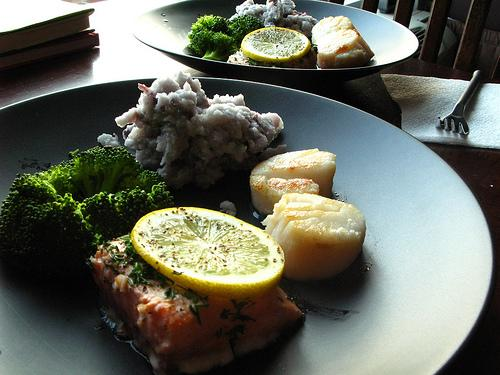What item is resting on the white napkin, and how would you describe it? A silver fork is resting on the white napkin, appearing clean and ready for use. Provide a high-level description of the entire scene captured in the image. The image shows a well-prepared seafood dish with broccoli and rice on a large white plate, placed on a wooden table with a silver fork on a white napkin, next to a stack of books and a wooden chair. Count the number of books present in the image and describe their state. There are two books in the image, neatly stacked on a table. Point out the two types of seafood on the white plate and describe how they are cooked. The plate has perfectly cooked white sea scallops and lemon herb cooked salmon, both visibly garnished with green herbs. How would you describe the arrangement and presentation of the seafood dish on the large white plate? The seafood dish is perfectly plated on the large white plate, with the cooked salmon, scallops, and broccoli well-arranged and garnished with green herbs and lemon. Describe the furniture visible in the image and its position relative to the food. A brown wooden chair with back slats is visible at the top-right corner of the image, placed beside the table with the food. What type of vegetable is presented along with the seafood, and where is it positioned in the image? Cooked green broccoli is presented with the seafood, positioned at the left side of the plate in the image. Describe the interactions between the objects in the image in terms of their placement and function. The seafood, rice, and broccoli are placed together on the white plate, creating an appetizing meal. A silver fork rests on a white napkin, prepared for use during the meal. The wooden table provides a surface for both the food and the stack of books, while the wooden chair offers seating for the person who will enjoy the meal. What is the sentiment implied by the visual elements in the image? The sentiment is positive, as the image portrays an appetizing and well-presented meal, inviting the viewer to enjoy a seafood feast. What is the main ingredient of the dish next to the broccoli? Salmon Chair and books bring delight. A moment of peace, captured with care. Choose the correct description of the plate with the seafood meal: (a) red plate with vegetables, (b) blue plate with seafood and rice, (c) green plate with fruits, (d) black plate with pasta (b) blue plate with seafood and rice Describe the appearance of the cooked salmon dish in the image. The cooked salmon dish has a lemon slice on top, green herbs, and appears pink in color. Is there a red fork on a green napkin? There is a silver fork mentioned repeatedly, but not a red one. Similarly, there are mentions of a white napkin and a blue cloth napkin but not a green one. Identify the event in the image. The event is a meal setup with plates of seafood dishes and utensils. Can you point to the pizza in the image? There is no mention of pizza in any of the captions, only various seafood dishes and side dishes like rice, broccoli, and lemon are mentioned. Identify if there are any diagrams in the image. No Create a story using the objects in the image. Once upon a time, a delicious seafood meal of salmon, scallops, and broccoli was prepared and presented on a blue and white plates. The silver fork sat neatly on a white napkin, the wooden chair was waiting for its guest, and the stack of books were ready to be explored after the meal. Everyone admired the presentation and enjoyed the flavors. Do you see any orange carrots on the plate with seafood? There is a seafood dish on a white plate and a blue plate, but carrots are not mentioned in any of the captions. There are other vegetables such as broccoli, but not carrots. Can you find the chocolate cake in the image? There is no mention of a chocolate cake, or any cake for that matter, in the image captions. The focus seems to be on a seafood meal, not dessert items. Are there any other objects sharing space with the seafood meal on the white plate? Yes, there is white rice and steamed broccoli What is the color of the plate with broccoli, seafood, and rice on it? Blue Identify the emotions shown in the image. There are no emotions depicted in the image. Explain the positioning of the objects on the wooden table. There are two plates with broccoli, seafood, and rice, a silver fork on a white napkin, a stack of books, and a wooden chair back. Can you find the blue and white striped chair in the image? There is a wooden chair with back slats mentioned, but there is no mention of stripes, and its color is brown, not blue. Describe the blue cloth item found in the image. The blue cloth item is a napkin placed under a silver fork. Describe the books in the image. The books are a stack of two on a table, with one having a dust jacket. Identify any instances of activity recognition in the image. There is no activity recognition in the image as there are no people or animals performing any actions. Please provide a short poem about the scene in the image. Upon the wooden table they lay, Is there a glass of wine next to the stack of books? Although there is mention of a stack of books, there is no mention of a glass of wine anywhere in the given image captions. 